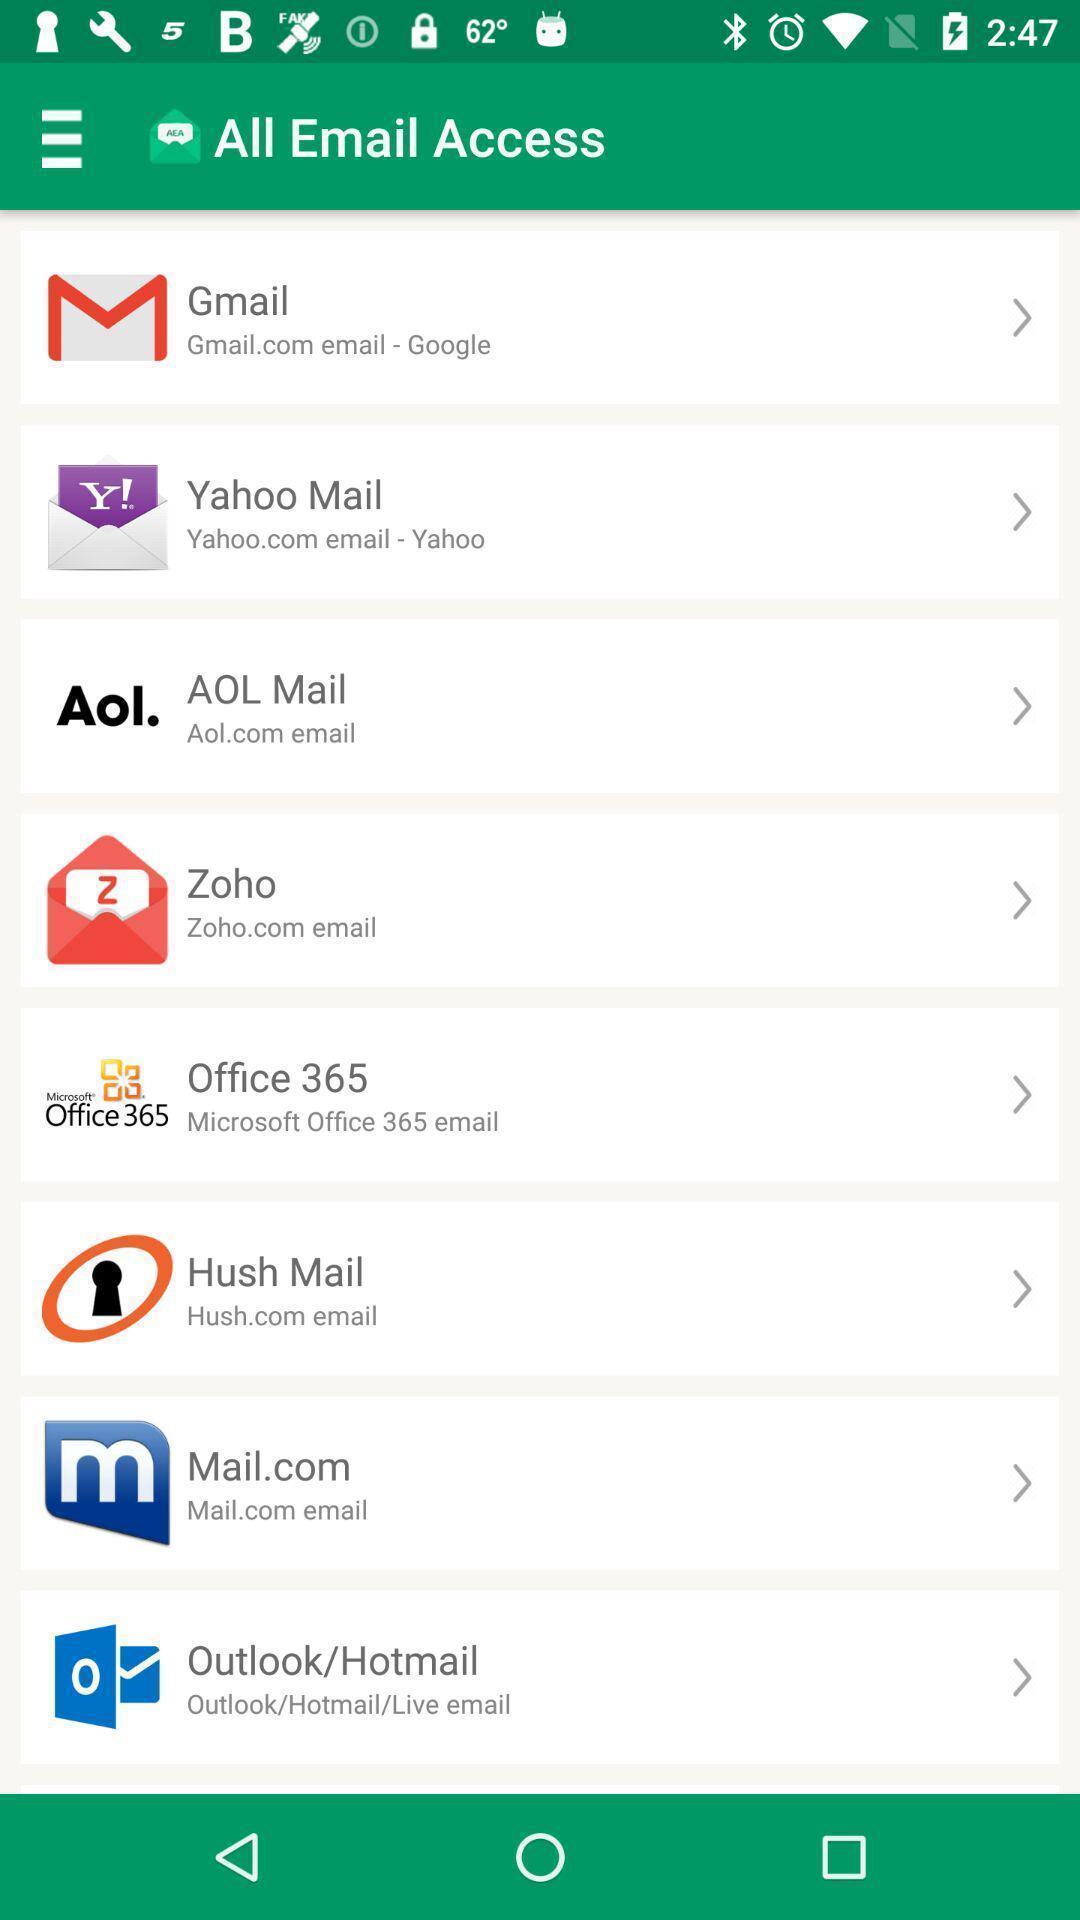Explain what's happening in this screen capture. Page shows the list of email applications. 